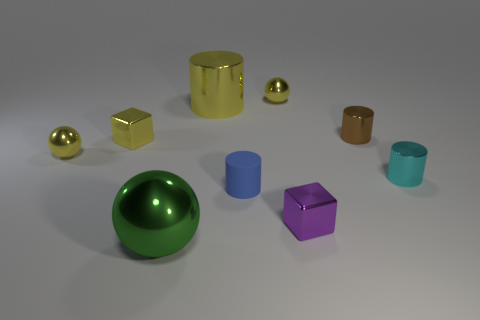Subtract all small blue matte cylinders. How many cylinders are left? 3 Subtract 2 cylinders. How many cylinders are left? 2 Add 1 cylinders. How many cylinders exist? 5 Add 1 blue shiny cubes. How many objects exist? 10 Subtract all purple blocks. How many blocks are left? 1 Subtract 0 cyan blocks. How many objects are left? 9 Subtract all cylinders. How many objects are left? 5 Subtract all red cubes. Subtract all brown cylinders. How many cubes are left? 2 Subtract all cyan balls. How many yellow blocks are left? 1 Subtract all shiny cubes. Subtract all big green shiny spheres. How many objects are left? 6 